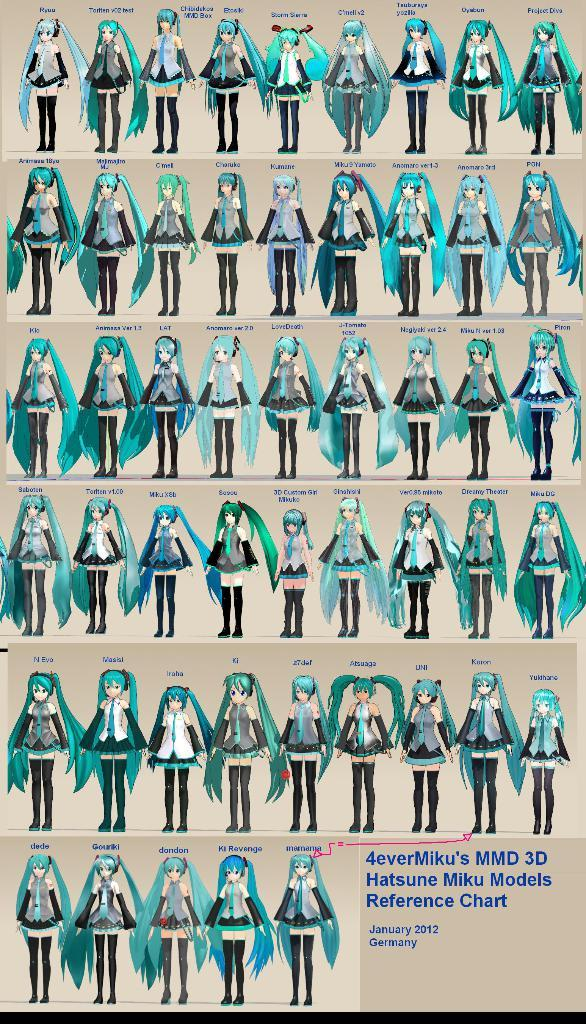What is the main subject of the image? The main subject of the image is a poster. What is depicted on the poster? There is a group of people standing on the poster. Is there any text on the poster? Yes, there is text at the bottom left of the poster. How many pieces of furniture can be seen on the poster? There is no furniture visible on the poster; it features a group of people standing. What type of chicken is present on the poster? There is no chicken present on the poster; it only features a group of people standing. 